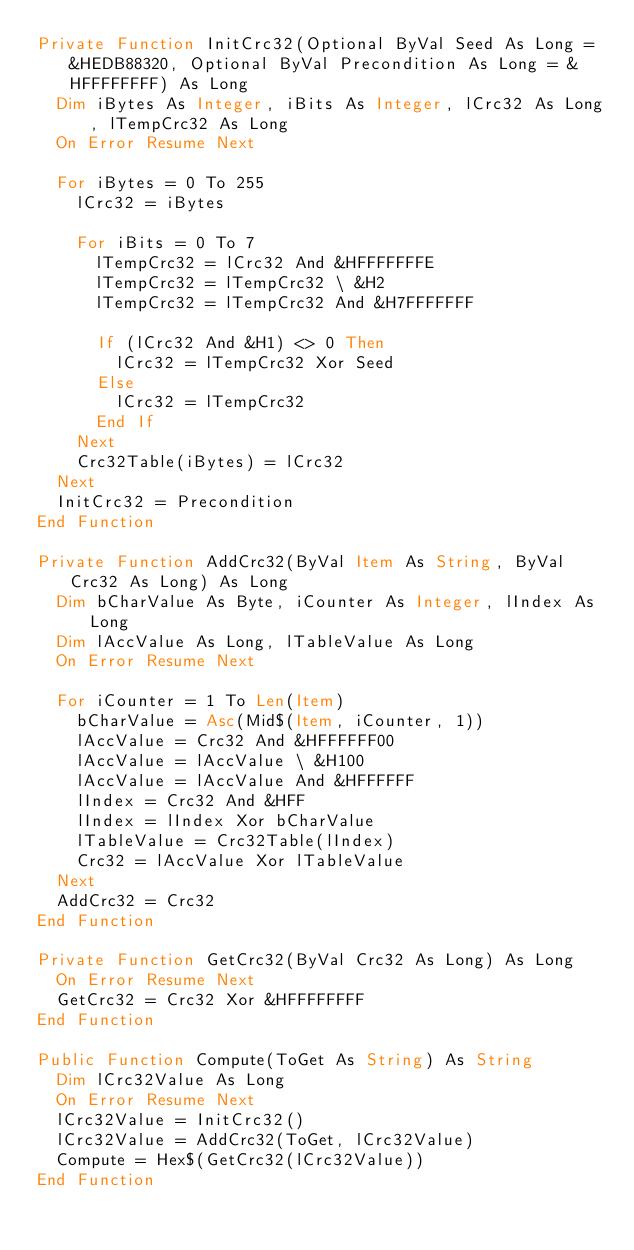<code> <loc_0><loc_0><loc_500><loc_500><_VisualBasic_>Private Function InitCrc32(Optional ByVal Seed As Long = &HEDB88320, Optional ByVal Precondition As Long = &HFFFFFFFF) As Long
  Dim iBytes As Integer, iBits As Integer, lCrc32 As Long, lTempCrc32 As Long
  On Error Resume Next

  For iBytes = 0 To 255
    lCrc32 = iBytes

    For iBits = 0 To 7
      lTempCrc32 = lCrc32 And &HFFFFFFFE
      lTempCrc32 = lTempCrc32 \ &H2
      lTempCrc32 = lTempCrc32 And &H7FFFFFFF

      If (lCrc32 And &H1) <> 0 Then
        lCrc32 = lTempCrc32 Xor Seed
      Else
        lCrc32 = lTempCrc32
      End If
    Next
    Crc32Table(iBytes) = lCrc32
  Next
  InitCrc32 = Precondition
End Function

Private Function AddCrc32(ByVal Item As String, ByVal Crc32 As Long) As Long
  Dim bCharValue As Byte, iCounter As Integer, lIndex As Long
  Dim lAccValue As Long, lTableValue As Long
  On Error Resume Next

  For iCounter = 1 To Len(Item)
    bCharValue = Asc(Mid$(Item, iCounter, 1))
    lAccValue = Crc32 And &HFFFFFF00
    lAccValue = lAccValue \ &H100
    lAccValue = lAccValue And &HFFFFFF
    lIndex = Crc32 And &HFF
    lIndex = lIndex Xor bCharValue
    lTableValue = Crc32Table(lIndex)
    Crc32 = lAccValue Xor lTableValue
  Next
  AddCrc32 = Crc32
End Function

Private Function GetCrc32(ByVal Crc32 As Long) As Long
  On Error Resume Next
  GetCrc32 = Crc32 Xor &HFFFFFFFF
End Function

Public Function Compute(ToGet As String) As String
  Dim lCrc32Value As Long
  On Error Resume Next
  lCrc32Value = InitCrc32()
  lCrc32Value = AddCrc32(ToGet, lCrc32Value)
  Compute = Hex$(GetCrc32(lCrc32Value))
End Function



</code> 